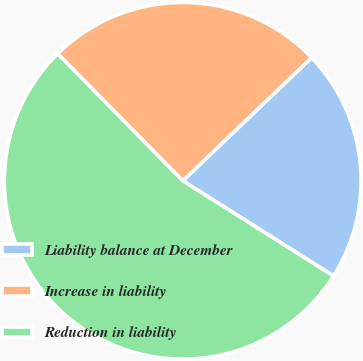Convert chart. <chart><loc_0><loc_0><loc_500><loc_500><pie_chart><fcel>Liability balance at December<fcel>Increase in liability<fcel>Reduction in liability<nl><fcel>21.11%<fcel>25.23%<fcel>53.66%<nl></chart> 